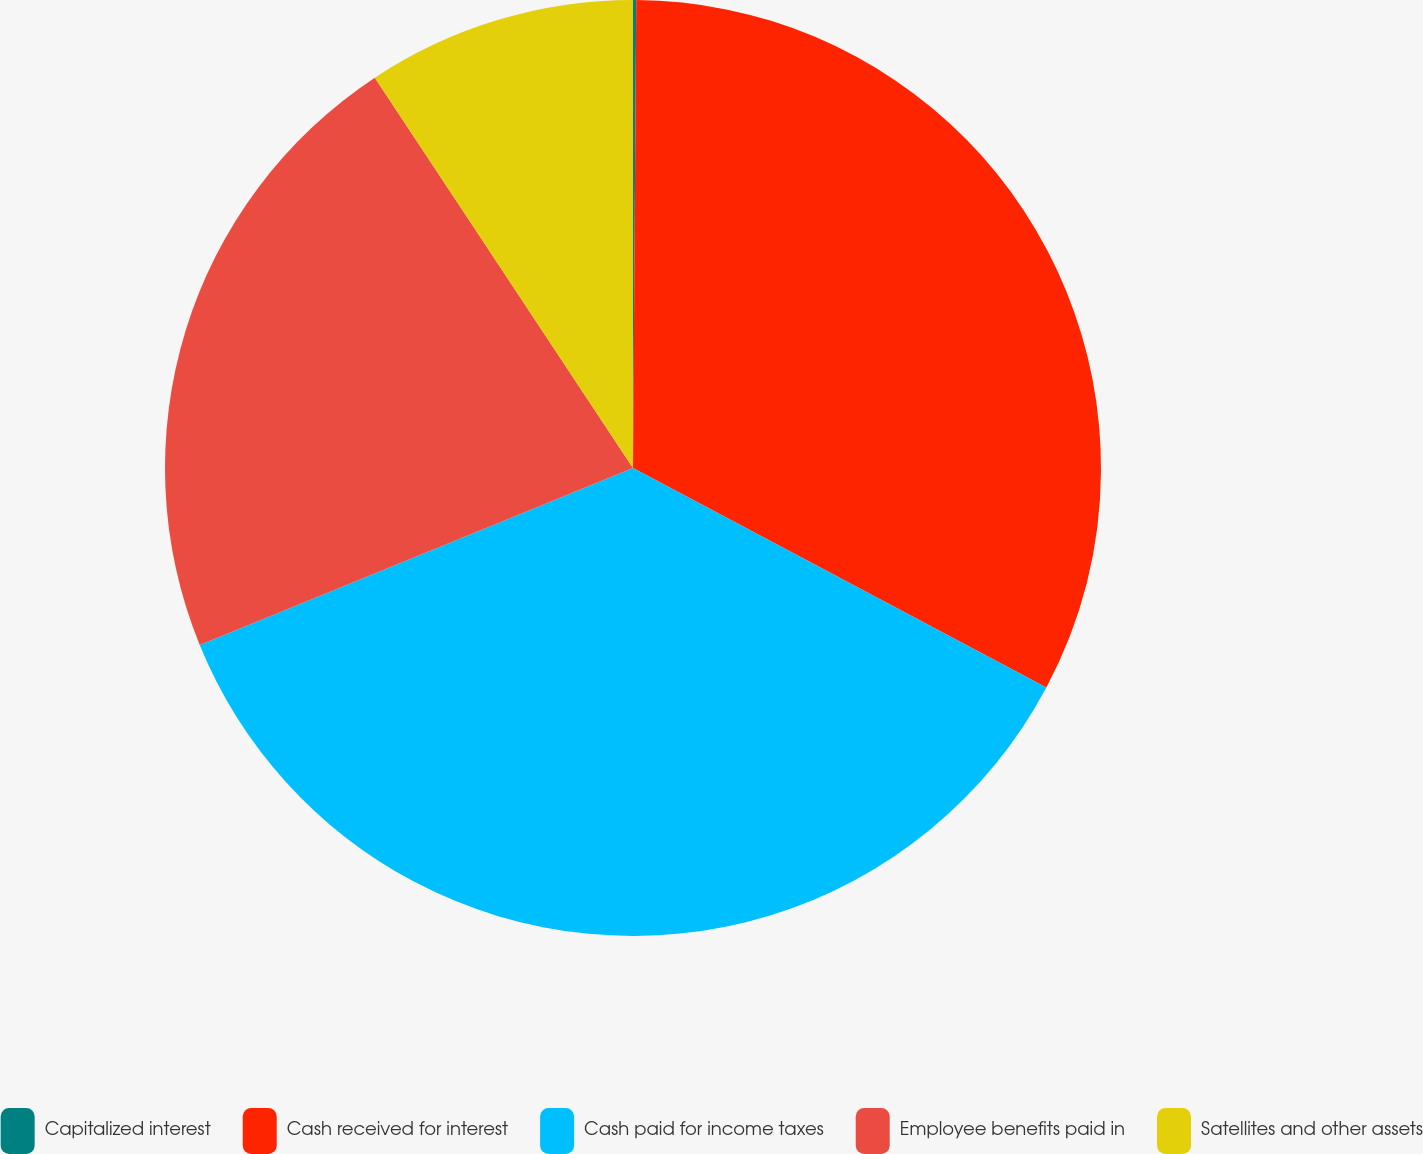Convert chart to OTSL. <chart><loc_0><loc_0><loc_500><loc_500><pie_chart><fcel>Capitalized interest<fcel>Cash received for interest<fcel>Cash paid for income taxes<fcel>Employee benefits paid in<fcel>Satellites and other assets<nl><fcel>0.11%<fcel>32.66%<fcel>36.06%<fcel>21.87%<fcel>9.3%<nl></chart> 